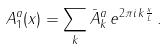Convert formula to latex. <formula><loc_0><loc_0><loc_500><loc_500>A _ { 1 } ^ { a } ( x ) = \sum _ { k } \bar { A } _ { k } ^ { a } \, e ^ { 2 \pi i \, k \frac { x } { L } } \, .</formula> 